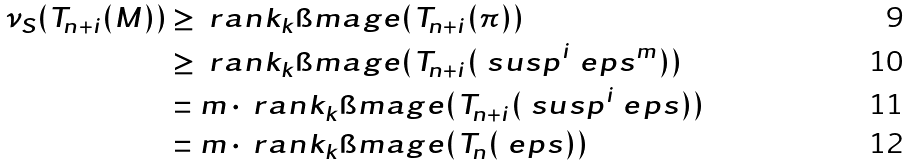Convert formula to latex. <formula><loc_0><loc_0><loc_500><loc_500>\nu _ { S } ( T _ { n + i } ( M ) ) & \geq \ r a n k _ { k } \i m a g e ( T _ { n + i } ( \pi ) ) \\ & \geq \ r a n k _ { k } \i m a g e ( T _ { n + i } ( \ s u s p ^ { i } \ e p s ^ { m } ) ) \\ & = m \cdot \ r a n k _ { k } \i m a g e ( T _ { n + i } ( \ s u s p ^ { i } \ e p s ) ) \\ & = m \cdot \ r a n k _ { k } \i m a g e ( T _ { n } ( \ e p s ) )</formula> 